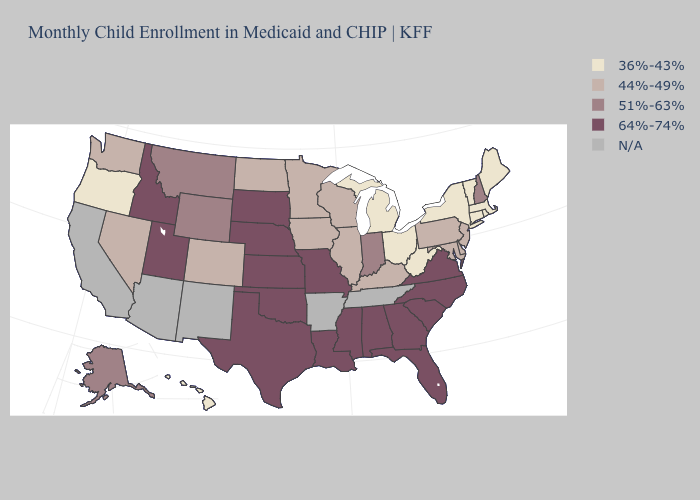What is the highest value in the MidWest ?
Concise answer only. 64%-74%. Among the states that border Iowa , which have the lowest value?
Answer briefly. Illinois, Minnesota, Wisconsin. What is the lowest value in the USA?
Be succinct. 36%-43%. Name the states that have a value in the range 51%-63%?
Keep it brief. Alaska, Indiana, Montana, New Hampshire, Wyoming. What is the value of New York?
Quick response, please. 36%-43%. Does Minnesota have the highest value in the USA?
Concise answer only. No. Is the legend a continuous bar?
Be succinct. No. What is the lowest value in the South?
Write a very short answer. 36%-43%. What is the value of Nebraska?
Be succinct. 64%-74%. What is the value of Alabama?
Short answer required. 64%-74%. Among the states that border Massachusetts , which have the lowest value?
Answer briefly. Connecticut, New York, Rhode Island, Vermont. Name the states that have a value in the range 64%-74%?
Short answer required. Alabama, Florida, Georgia, Idaho, Kansas, Louisiana, Mississippi, Missouri, Nebraska, North Carolina, Oklahoma, South Carolina, South Dakota, Texas, Utah, Virginia. 